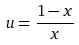<formula> <loc_0><loc_0><loc_500><loc_500>u = \frac { 1 - x } { x }</formula> 